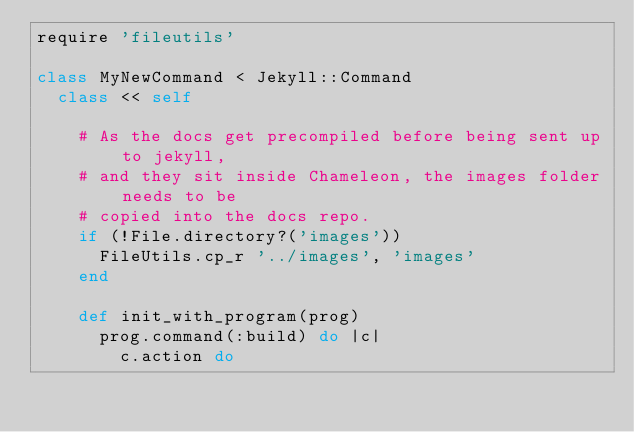Convert code to text. <code><loc_0><loc_0><loc_500><loc_500><_Ruby_>require 'fileutils'

class MyNewCommand < Jekyll::Command
  class << self

    # As the docs get precompiled before being sent up to jekyll,
    # and they sit inside Chameleon, the images folder needs to be
    # copied into the docs repo.
    if (!File.directory?('images'))
      FileUtils.cp_r '../images', 'images'
    end

    def init_with_program(prog)
      prog.command(:build) do |c|
        c.action do</code> 